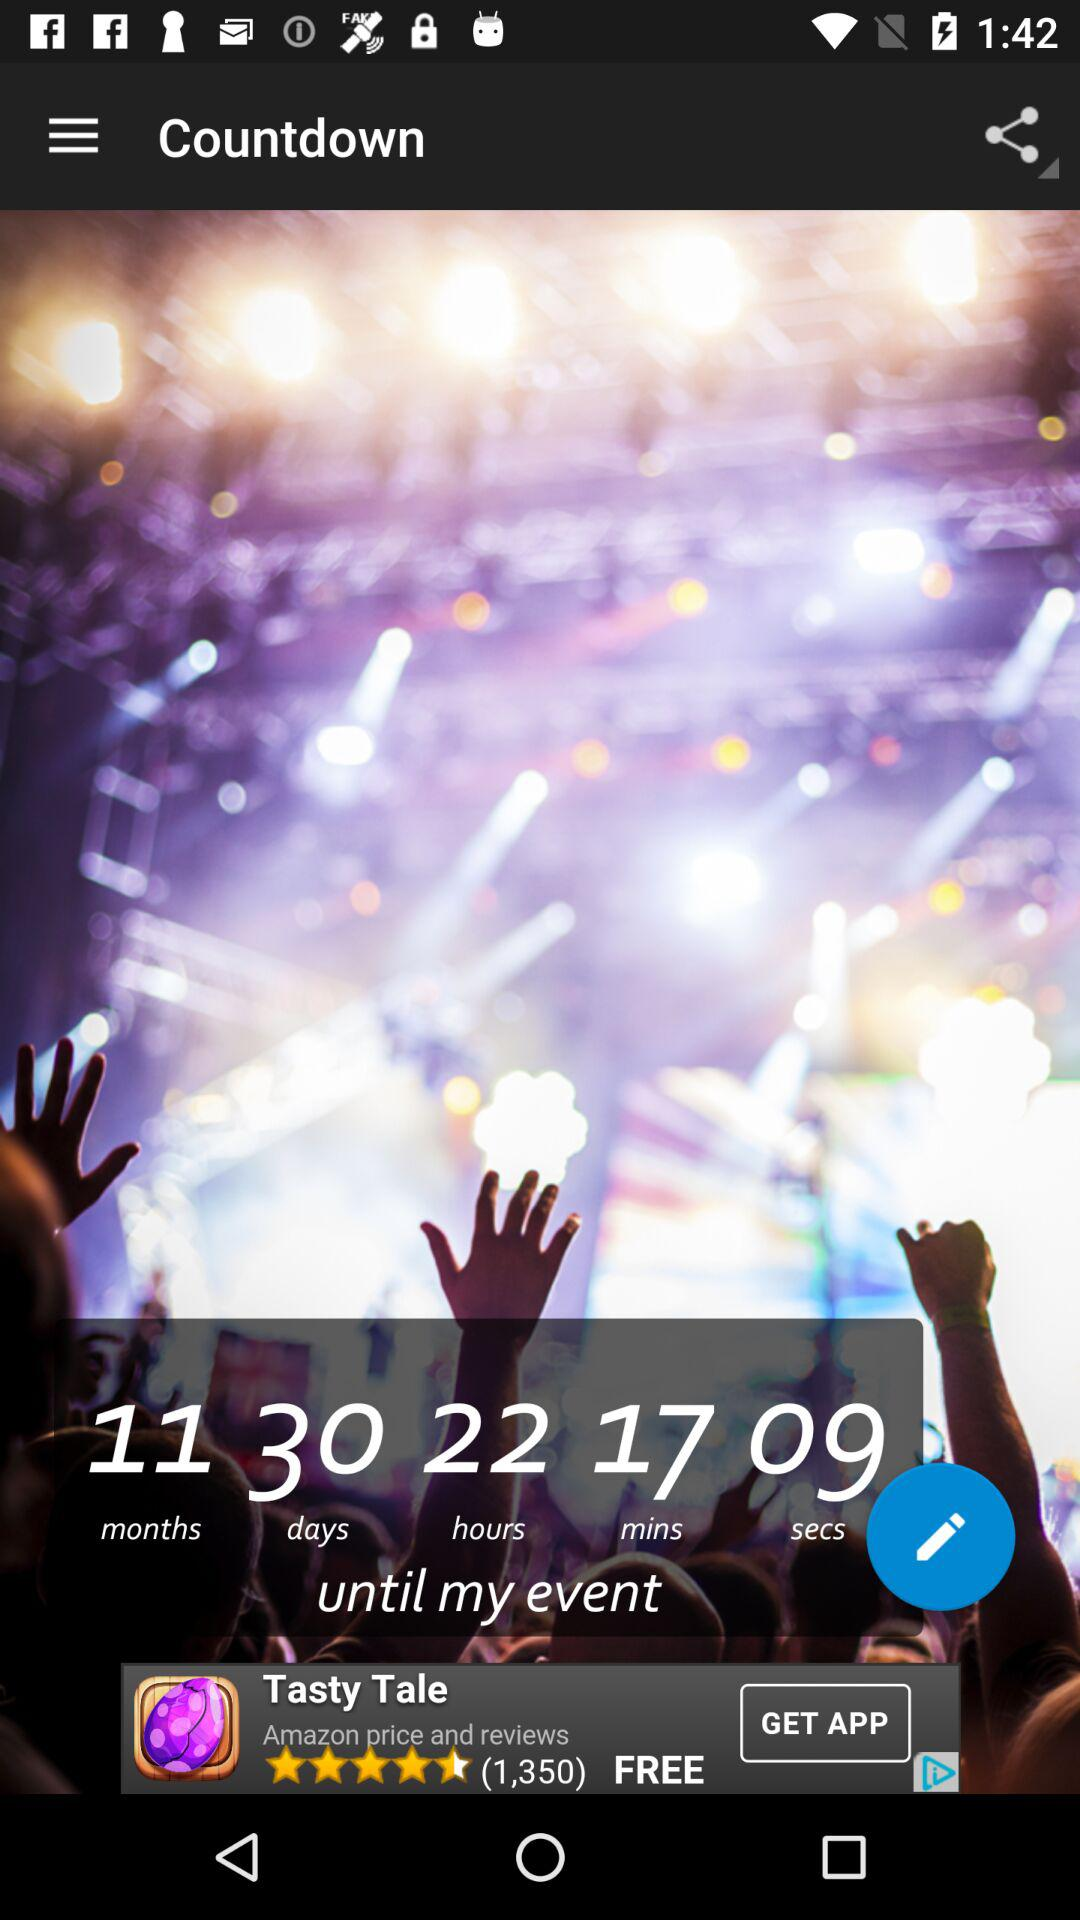How much time is left for the event to be held? The time left for the event to be held is 11 months, 30 days, 22 hours, 17 minutes and 9 seconds. 